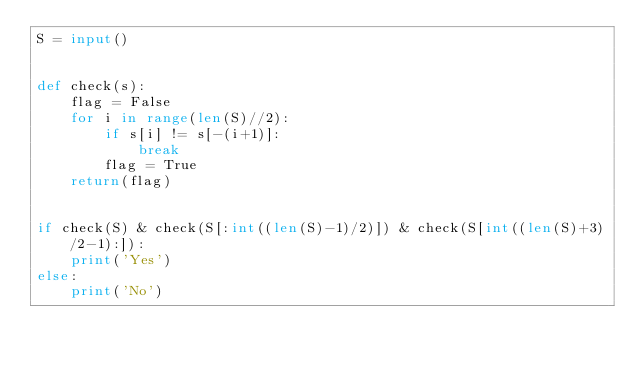Convert code to text. <code><loc_0><loc_0><loc_500><loc_500><_Python_>S = input()


def check(s):
    flag = False
    for i in range(len(S)//2):
        if s[i] != s[-(i+1)]:
            break
        flag = True
    return(flag)


if check(S) & check(S[:int((len(S)-1)/2)]) & check(S[int((len(S)+3)/2-1):]):
    print('Yes')
else:
    print('No')
</code> 